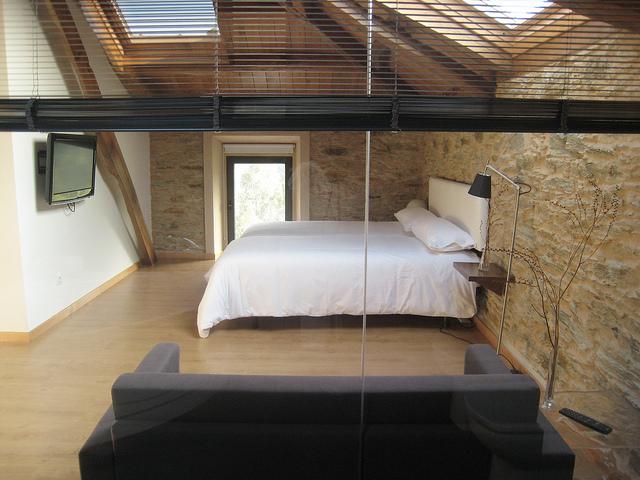Does this room have a skylight?
Keep it brief. Yes. What is the material used on the walls of the house?
Quick response, please. Stone. Is this a bedroom?
Write a very short answer. Yes. 